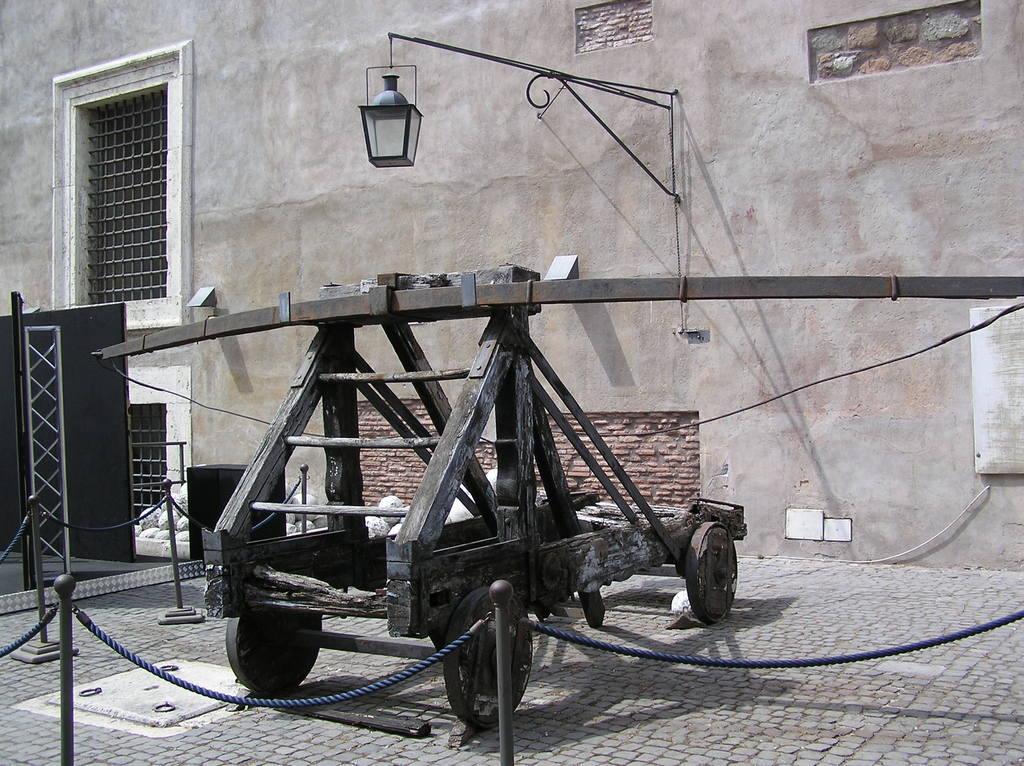Can you describe this image briefly? In this image in front there is a metal fence. In front of the metal fence there is a vehicle on the road. In the background of the image there is a wall. In front of the wall there is a light. On the left side of the image there are windows. In front of the window there is some object. 